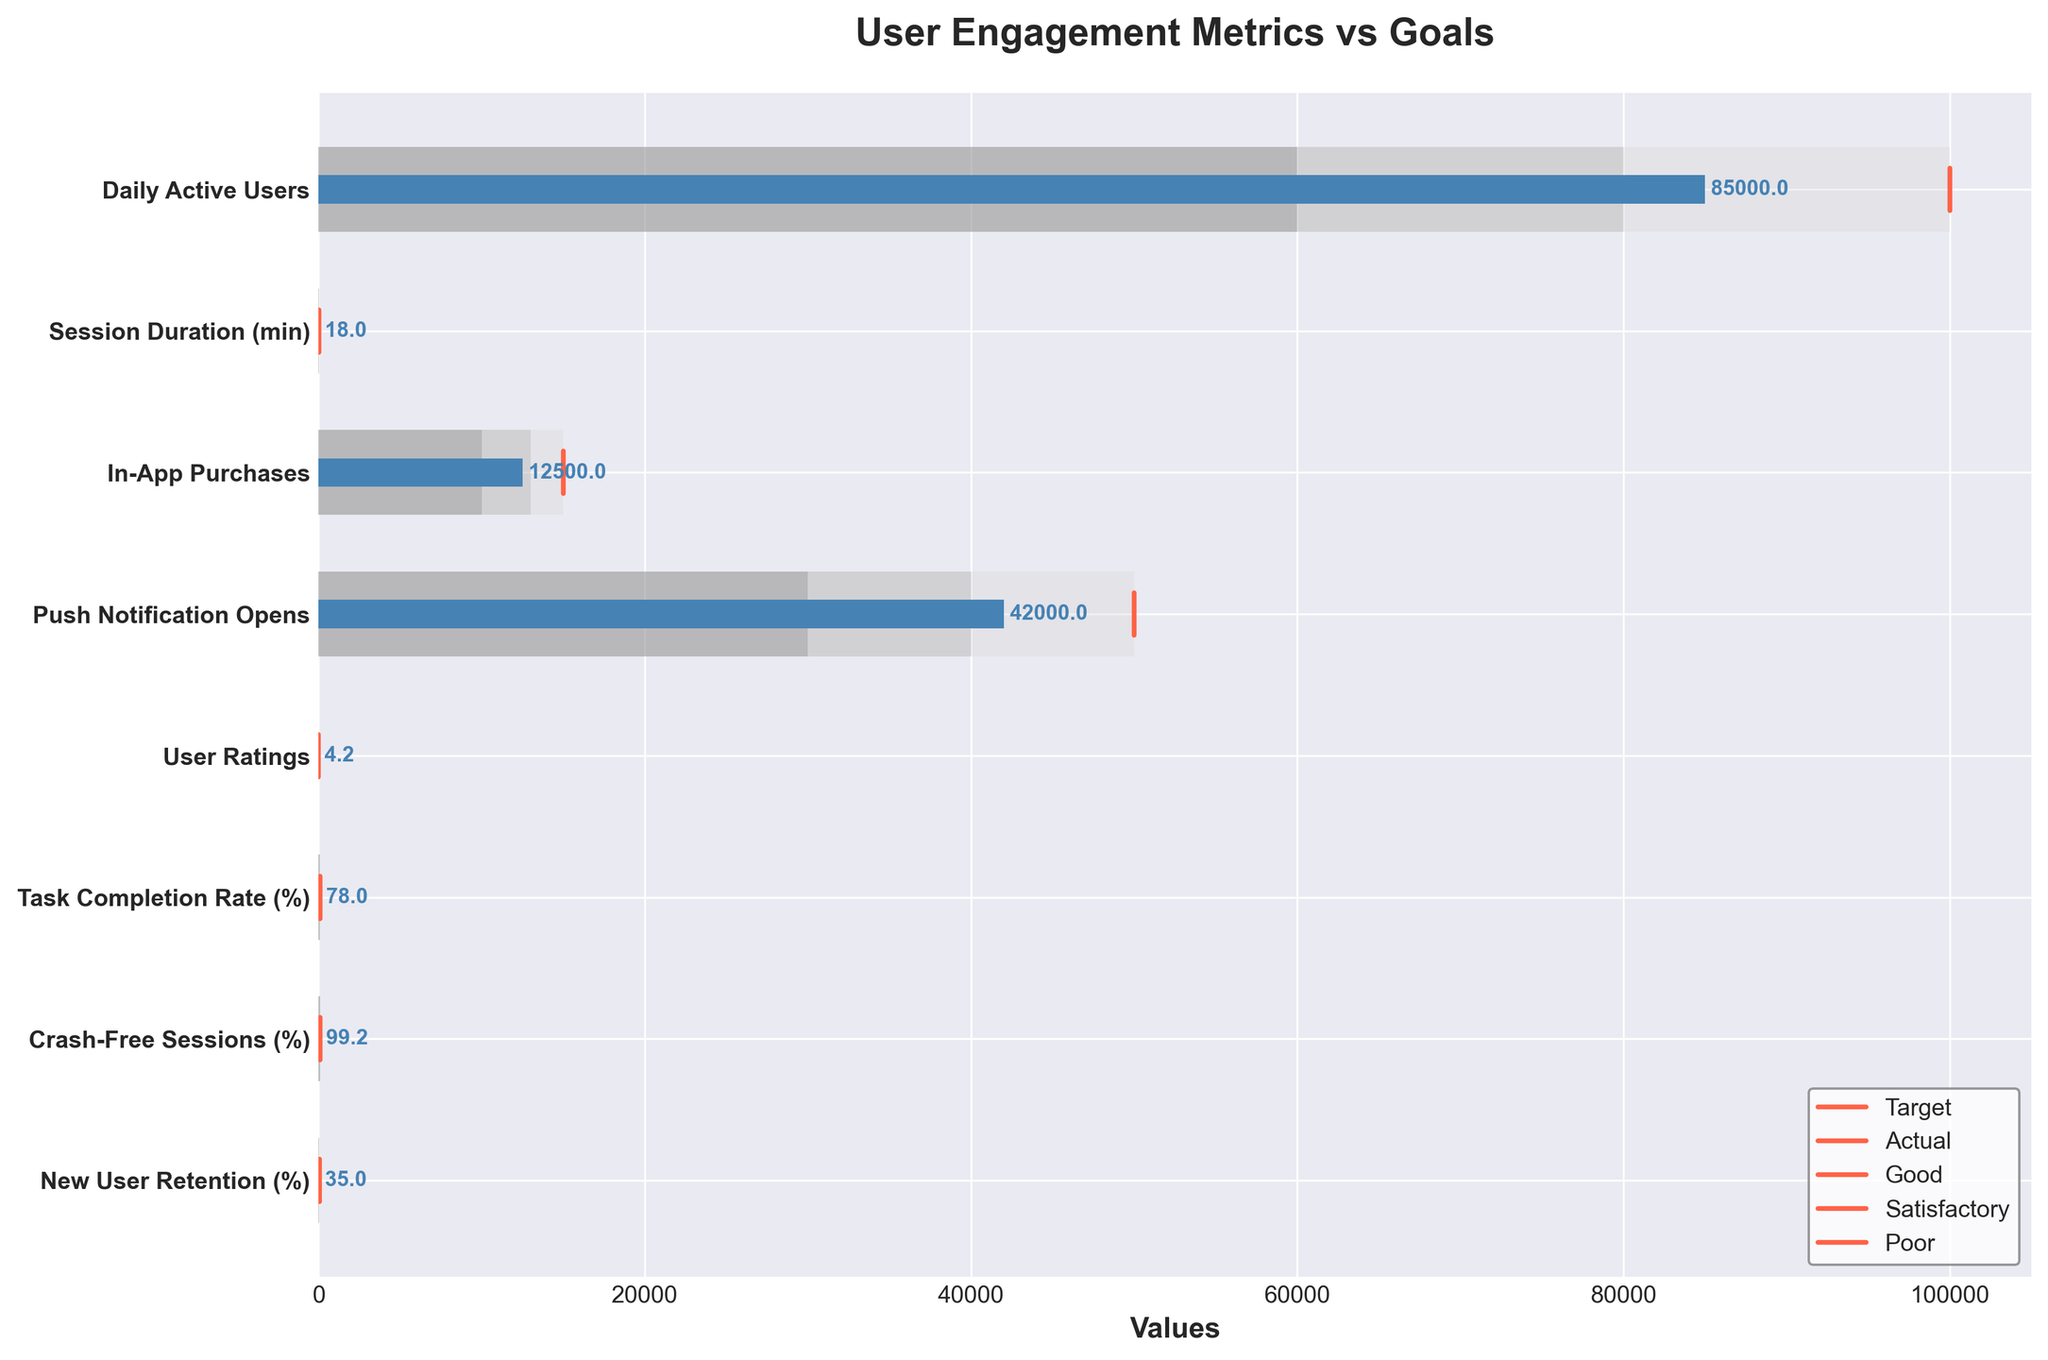What's the title of the figure? The title of the figure is displayed at the top and reads "User Engagement Metrics vs Goals".
Answer: User Engagement Metrics vs Goals What does the y-axis represent in the bullet chart? The y-axis shows the different features of the app, such as Daily Active Users, Session Duration, etc.
Answer: Features of the app Which feature has the highest actual value? By looking at the actual values in blue, the feature with the highest actual value is Daily Active Users, with a value of 85,000.
Answer: Daily Active Users Which feature is closest to meeting its target value? By comparing the lengths of the blue bars to their corresponding red target lines, Crash-Free Sessions (99.2%) is the closest to its target of 99.5%.
Answer: Crash-Free Sessions How many features met their target values? None of the blue bars reach their respective red target lines, so no features have met their target values.
Answer: None What is the difference between the target and actual values for Session Duration? The target value for Session Duration is 25, and the actual value is 18. The difference is 25 - 18 = 7.
Answer: 7 Which feature is performing the poorest compared to its target? By comparing the distance between the actual values (blue bars) and the target values (red lines), New User Retention (35%) is performing the poorest compared to its target of 45%.
Answer: New User Retention For the feature In-App Purchases, how far is the actual value from the satisfactory range? The satisfactory range starts at 13,000, and the actual value is 12,500, so it falls short by 13,000 - 12,500 = 500.
Answer: 500 Are there any features where the actual value is within the good range? Yes, the actual value for User Ratings (4.2) is between 4.0 and 4.5, which falls within the good range.
Answer: User Ratings Which features have actual values that fall into the poor range? The features where the blue bars fall into the gray (poor) areas are Daily Active Users, Session Duration, In-App Purchases, Push Notification Opens, Task Completion Rate, and New User Retention.
Answer: Daily Active Users, Session Duration, In-App Purchases, Push Notification Opens, Task Completion Rate, New User Retention 